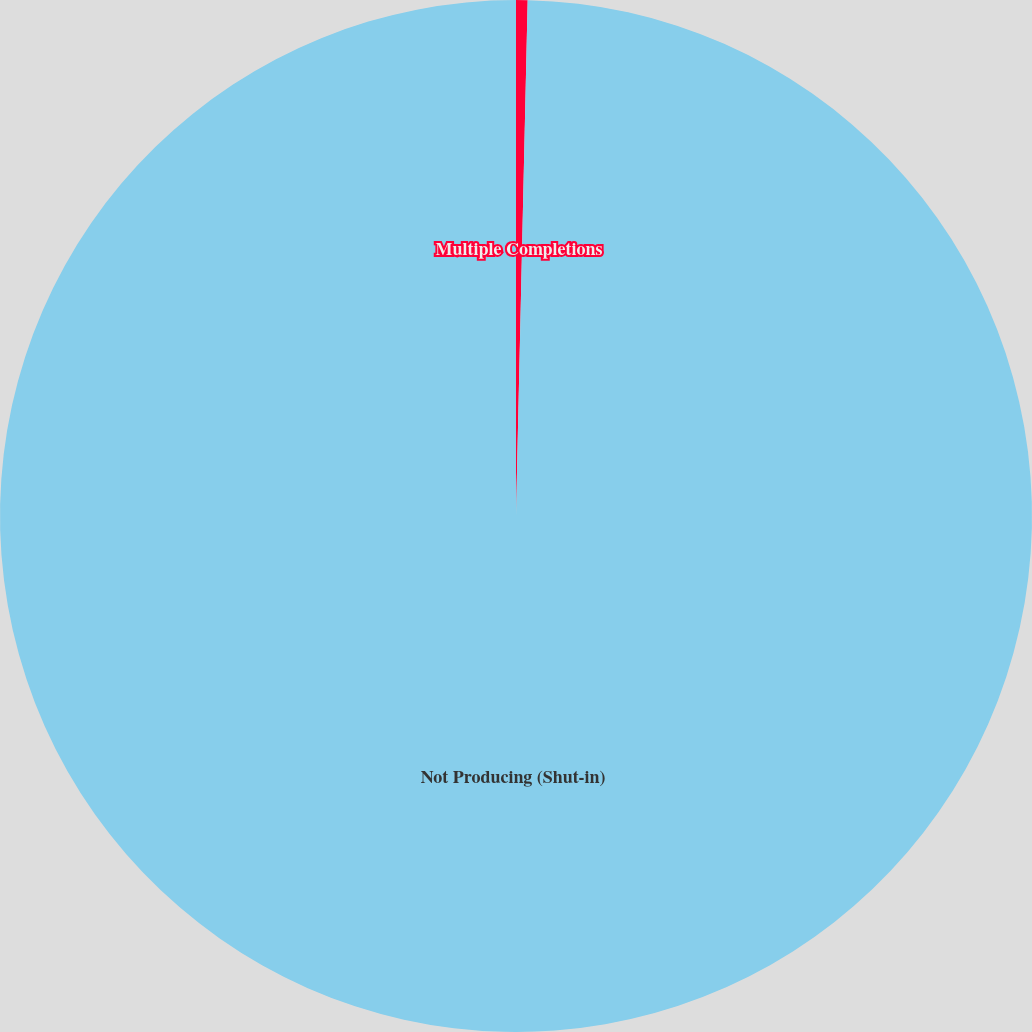<chart> <loc_0><loc_0><loc_500><loc_500><pie_chart><fcel>Multiple Completions<fcel>Not Producing (Shut-in)<nl><fcel>0.36%<fcel>99.64%<nl></chart> 